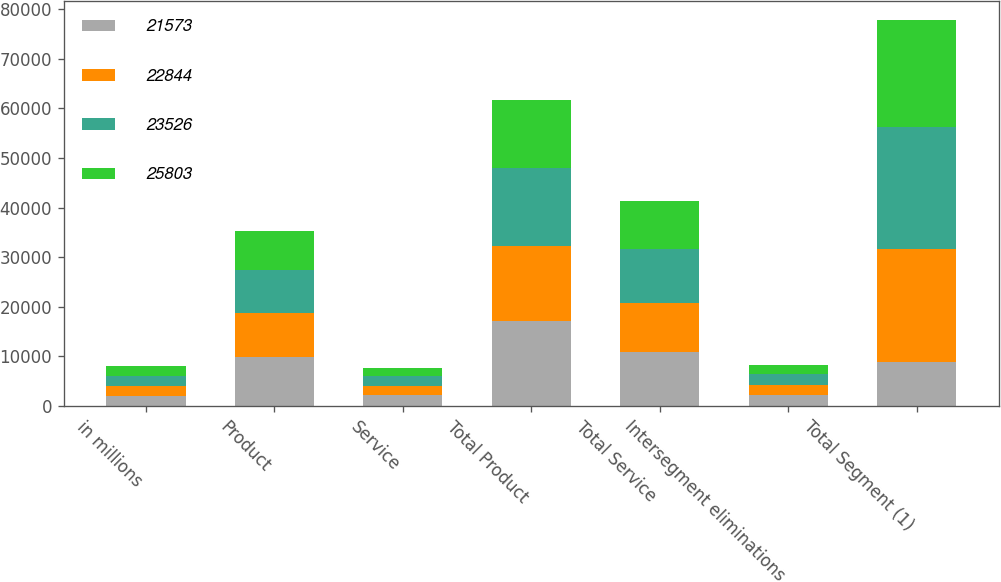Convert chart to OTSL. <chart><loc_0><loc_0><loc_500><loc_500><stacked_bar_chart><ecel><fcel>in millions<fcel>Product<fcel>Service<fcel>Total Product<fcel>Total Service<fcel>Intersegment eliminations<fcel>Total Segment (1)<nl><fcel>21573<fcel>2017<fcel>9841<fcel>2114<fcel>17140<fcel>10947<fcel>2284<fcel>8796<nl><fcel>22844<fcel>2017<fcel>8796<fcel>1900<fcel>15137<fcel>9714<fcel>2007<fcel>22844<nl><fcel>23526<fcel>2016<fcel>8868<fcel>1960<fcel>15659<fcel>10922<fcel>2073<fcel>24508<nl><fcel>25803<fcel>2016<fcel>7837<fcel>1755<fcel>13717<fcel>9671<fcel>1815<fcel>21573<nl></chart> 